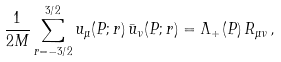Convert formula to latex. <formula><loc_0><loc_0><loc_500><loc_500>\frac { 1 } { 2 M } \sum _ { r = - 3 / 2 } ^ { 3 / 2 } u _ { \mu } ( P ; r ) \, \bar { u } _ { \nu } ( P ; r ) = \Lambda _ { + } ( P ) \, R _ { \mu \nu } \, ,</formula> 